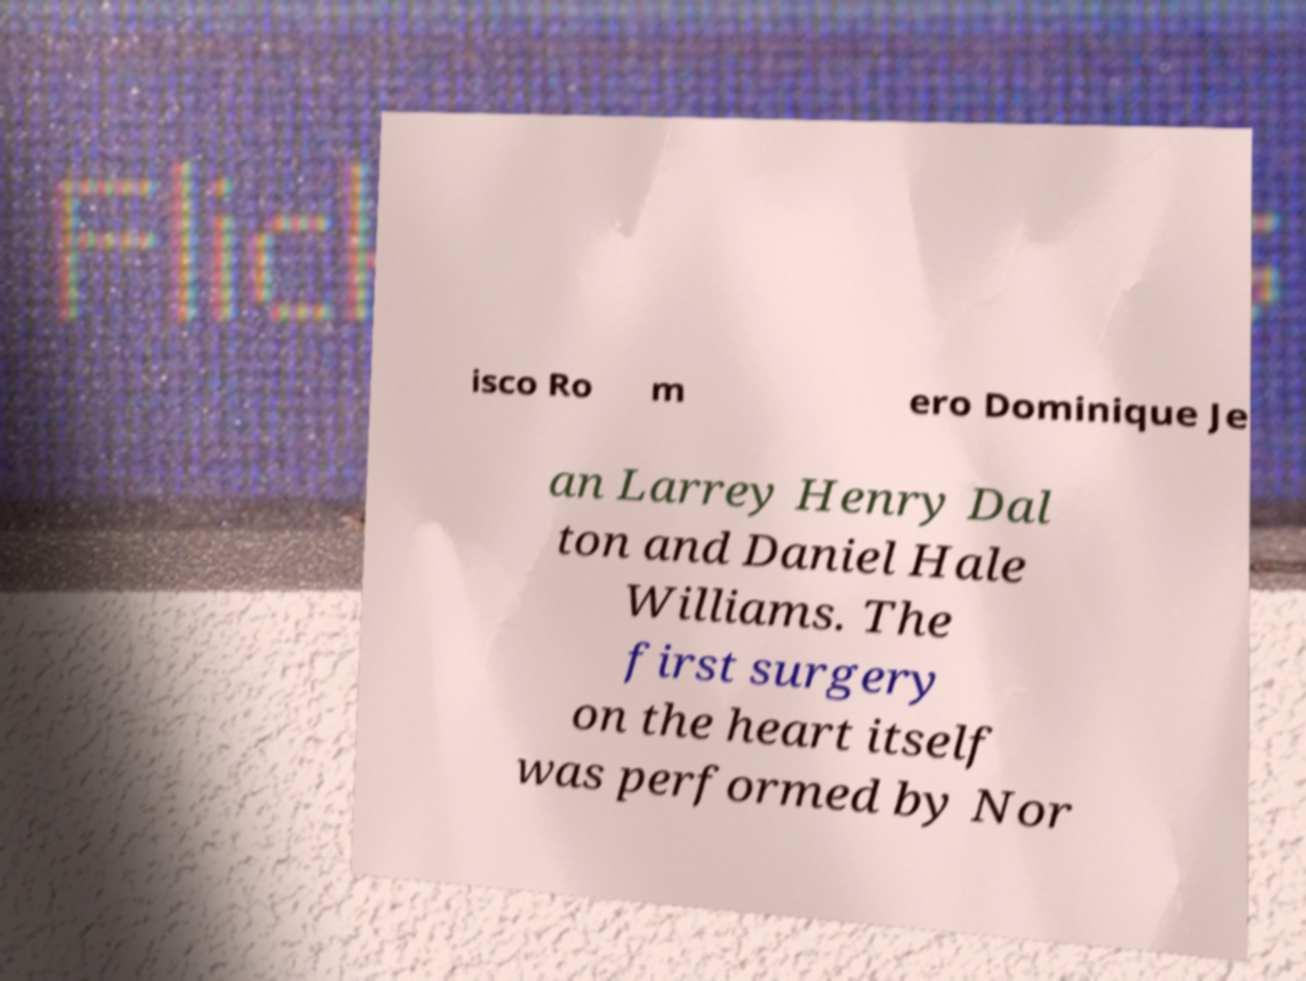Can you read and provide the text displayed in the image?This photo seems to have some interesting text. Can you extract and type it out for me? isco Ro m ero Dominique Je an Larrey Henry Dal ton and Daniel Hale Williams. The first surgery on the heart itself was performed by Nor 